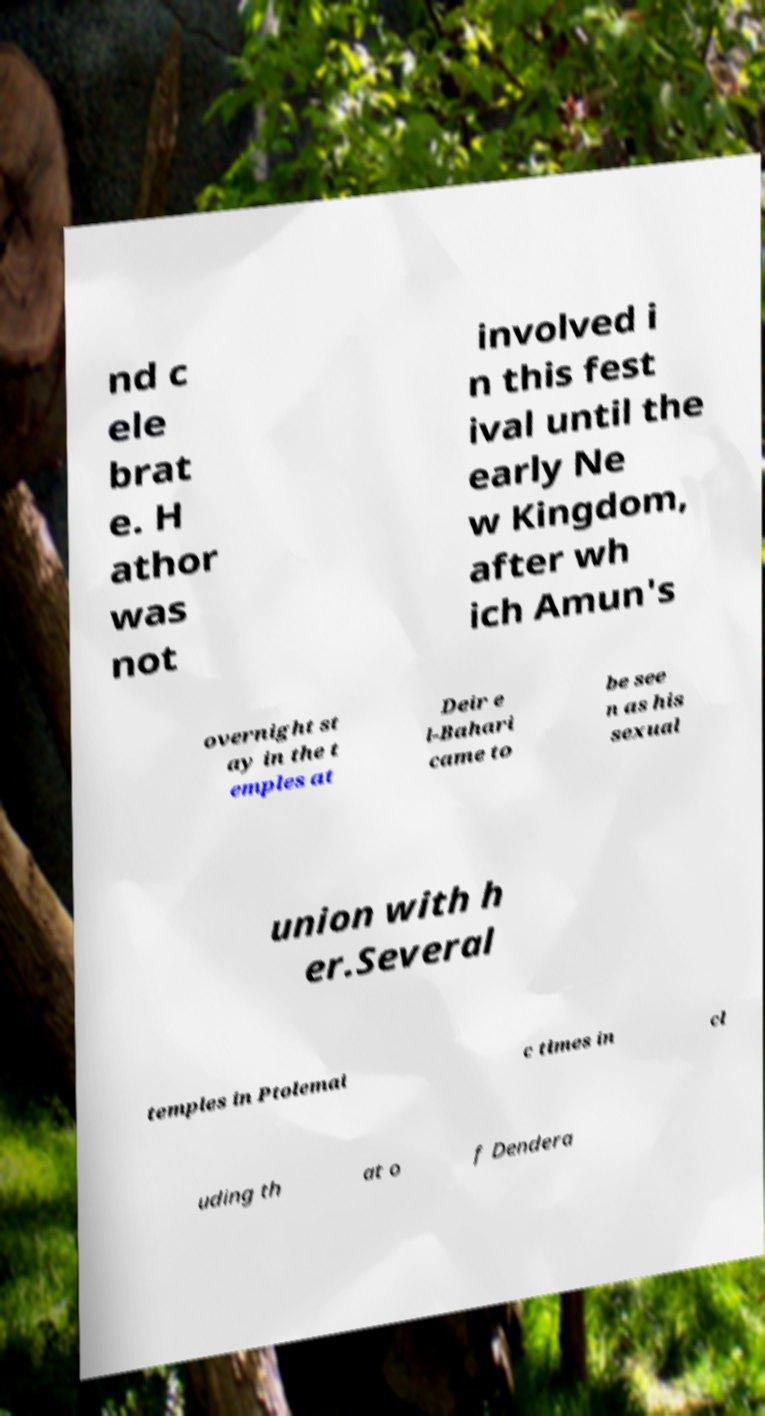For documentation purposes, I need the text within this image transcribed. Could you provide that? nd c ele brat e. H athor was not involved i n this fest ival until the early Ne w Kingdom, after wh ich Amun's overnight st ay in the t emples at Deir e l-Bahari came to be see n as his sexual union with h er.Several temples in Ptolemai c times in cl uding th at o f Dendera 